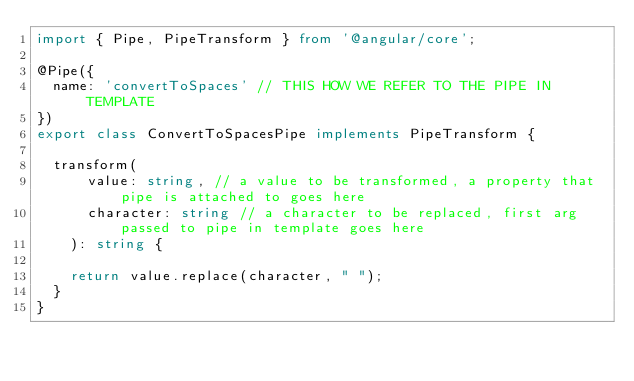<code> <loc_0><loc_0><loc_500><loc_500><_TypeScript_>import { Pipe, PipeTransform } from '@angular/core';

@Pipe({
  name: 'convertToSpaces' // THIS HOW WE REFER TO THE PIPE IN TEMPLATE
})
export class ConvertToSpacesPipe implements PipeTransform {

  transform(
      value: string, // a value to be transformed, a property that pipe is attached to goes here
      character: string // a character to be replaced, first arg passed to pipe in template goes here
    ): string {
          
    return value.replace(character, " ");
  }
}
</code> 